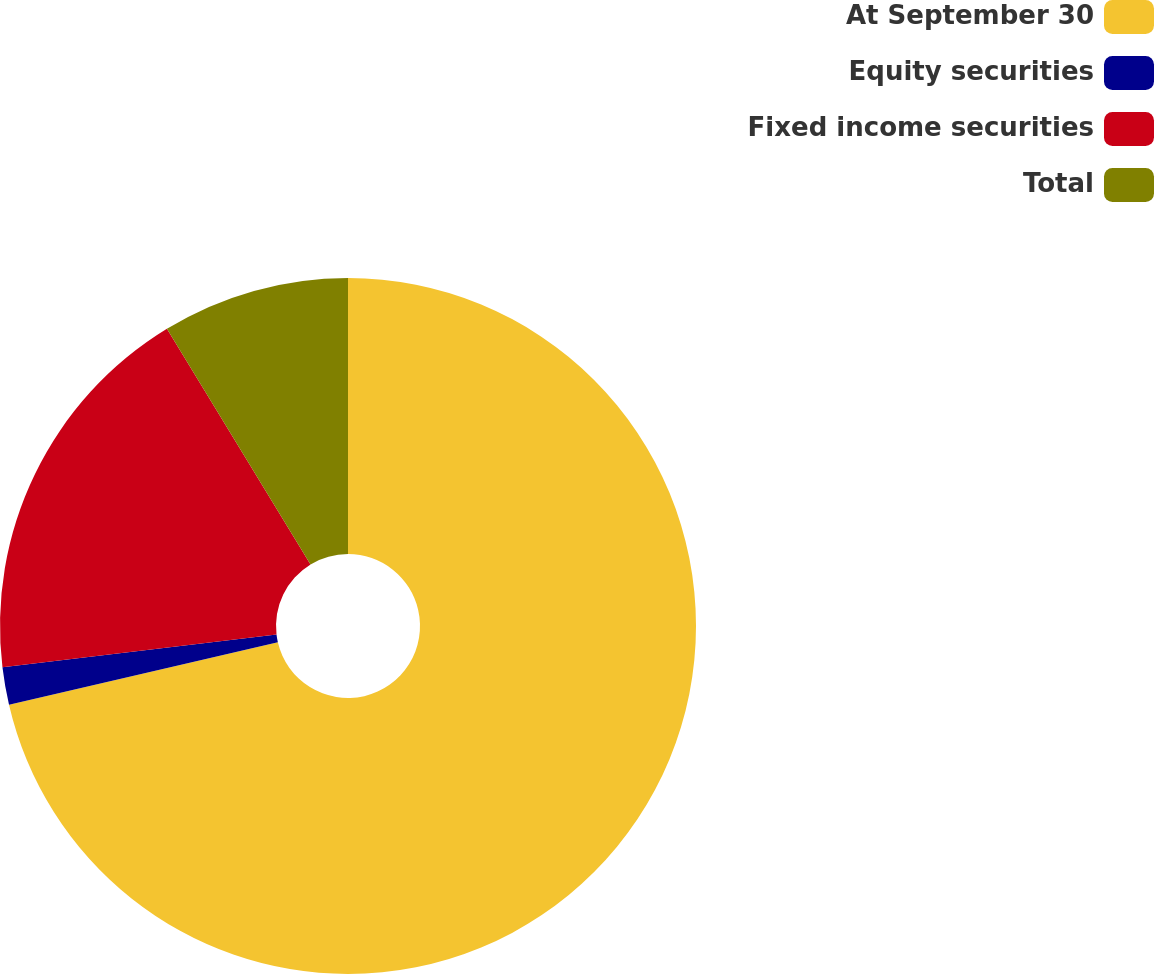Convert chart to OTSL. <chart><loc_0><loc_0><loc_500><loc_500><pie_chart><fcel>At September 30<fcel>Equity securities<fcel>Fixed income securities<fcel>Total<nl><fcel>71.37%<fcel>1.74%<fcel>18.18%<fcel>8.71%<nl></chart> 